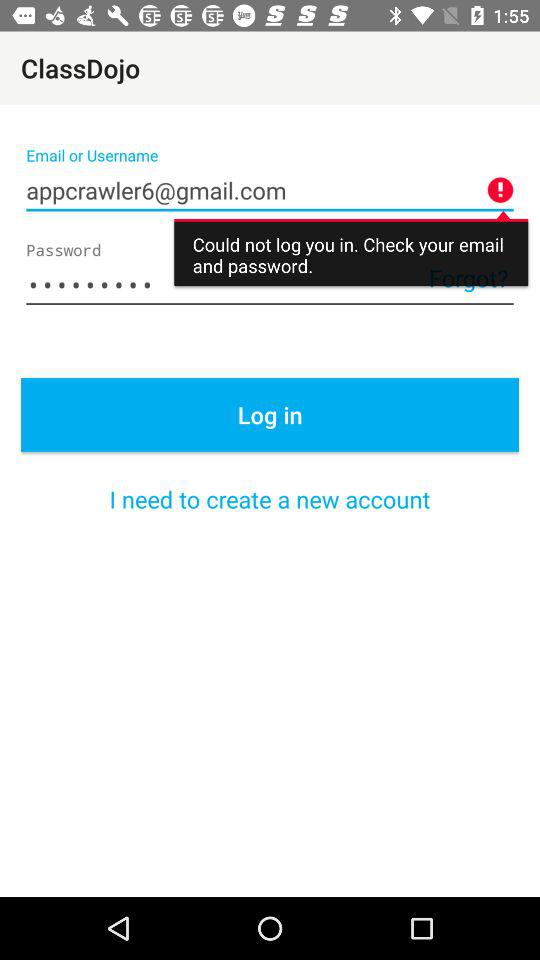What is the email address? The email address is appcrawler6@gmail.com. 